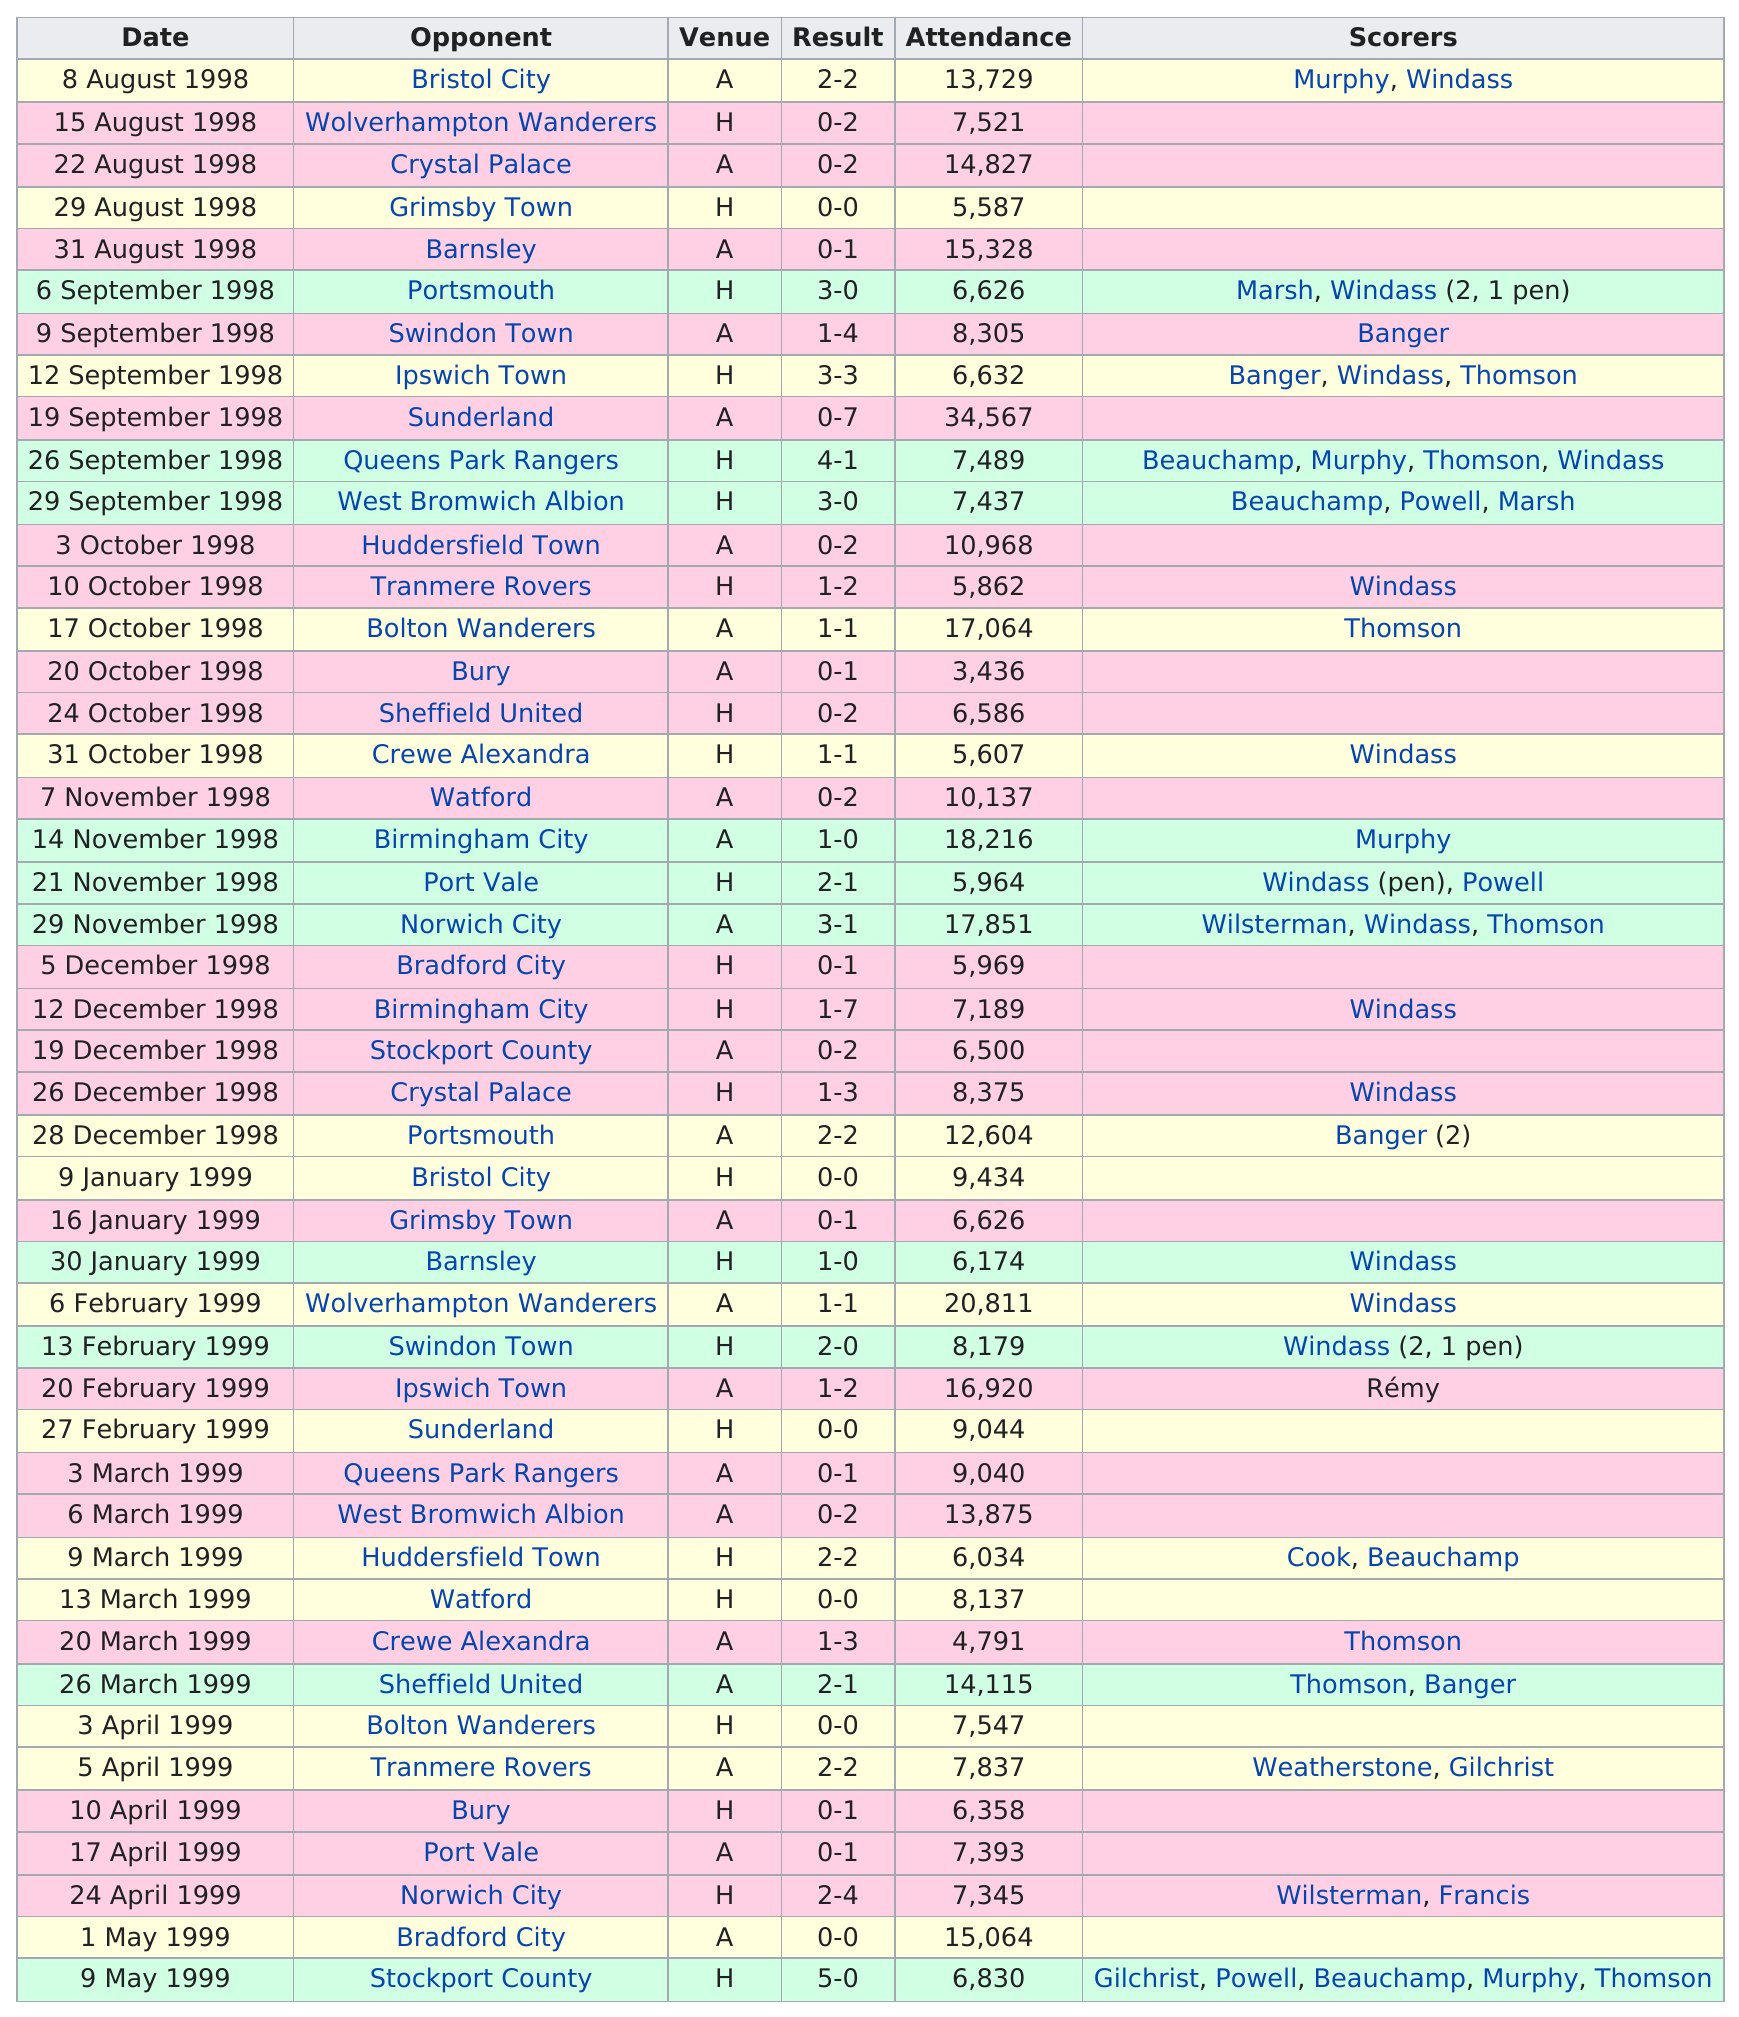Give some essential details in this illustration. On [insert date], Oxford United FC defeated their first opponent of the season, Portsmouth, in a hard-fought match. Portsmouth was the first to achieve the best result. On September 19, 1998, the game with the most number of people in attendance was played. In August 1998, Oxford United F.C. played a total of 5 games. Oxford United F.C. played a total of 46 matches during the season. 